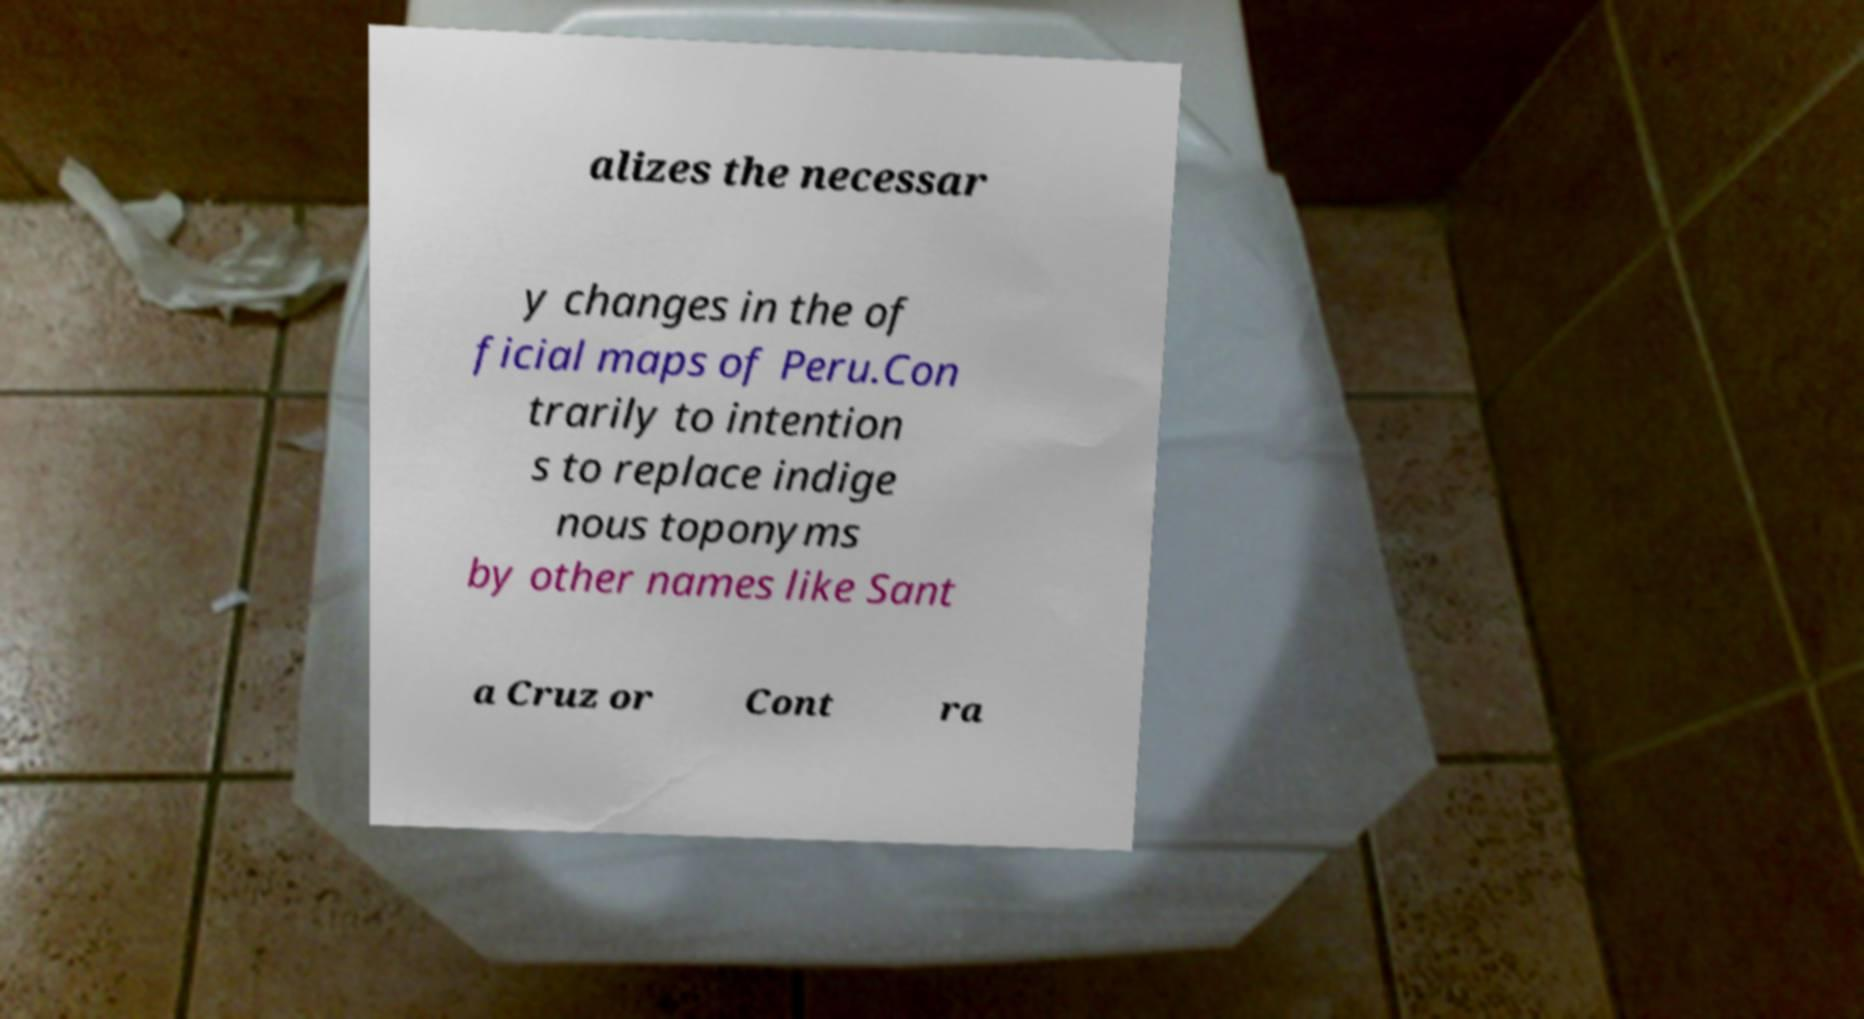Could you extract and type out the text from this image? alizes the necessar y changes in the of ficial maps of Peru.Con trarily to intention s to replace indige nous toponyms by other names like Sant a Cruz or Cont ra 